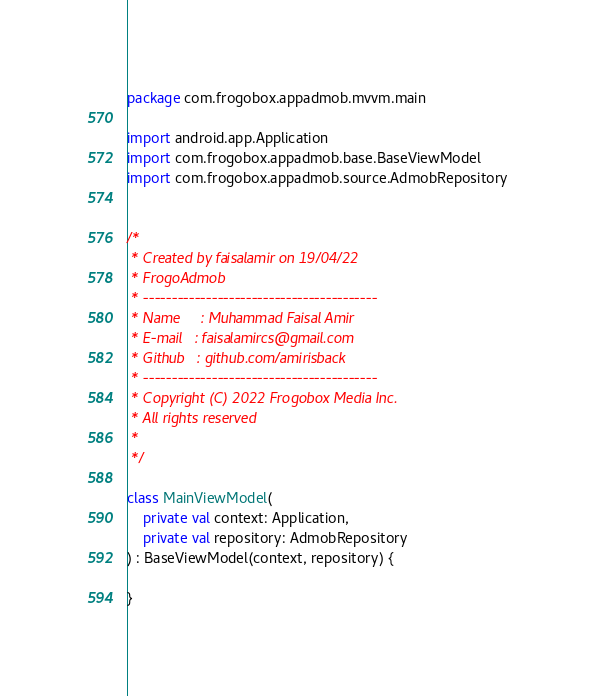Convert code to text. <code><loc_0><loc_0><loc_500><loc_500><_Kotlin_>package com.frogobox.appadmob.mvvm.main

import android.app.Application
import com.frogobox.appadmob.base.BaseViewModel
import com.frogobox.appadmob.source.AdmobRepository


/*
 * Created by faisalamir on 19/04/22
 * FrogoAdmob
 * -----------------------------------------
 * Name     : Muhammad Faisal Amir
 * E-mail   : faisalamircs@gmail.com
 * Github   : github.com/amirisback
 * -----------------------------------------
 * Copyright (C) 2022 Frogobox Media Inc.      
 * All rights reserved
 *
 */

class MainViewModel(
    private val context: Application,
    private val repository: AdmobRepository
) : BaseViewModel(context, repository) {

}</code> 